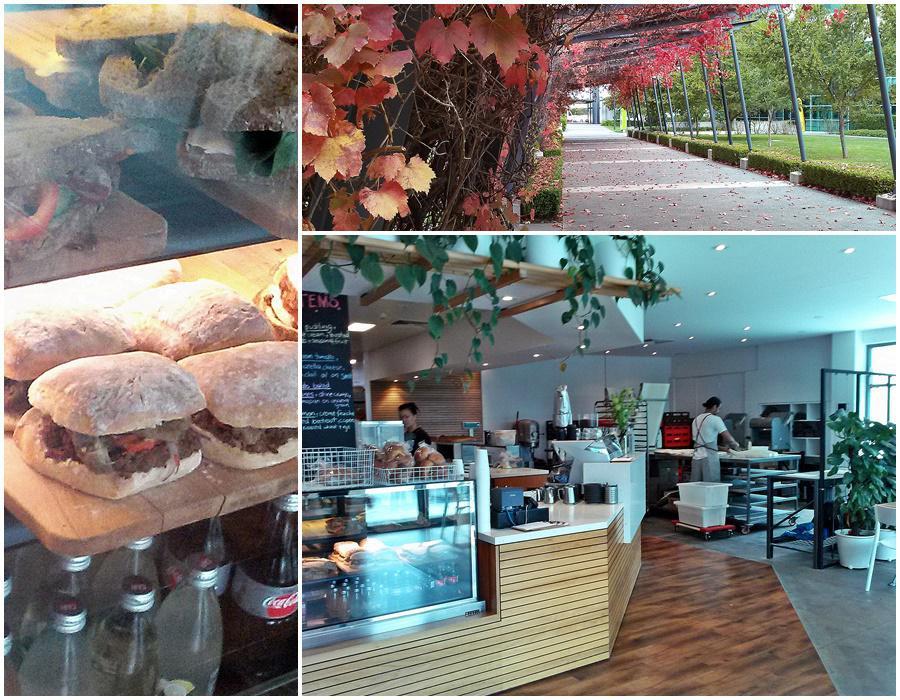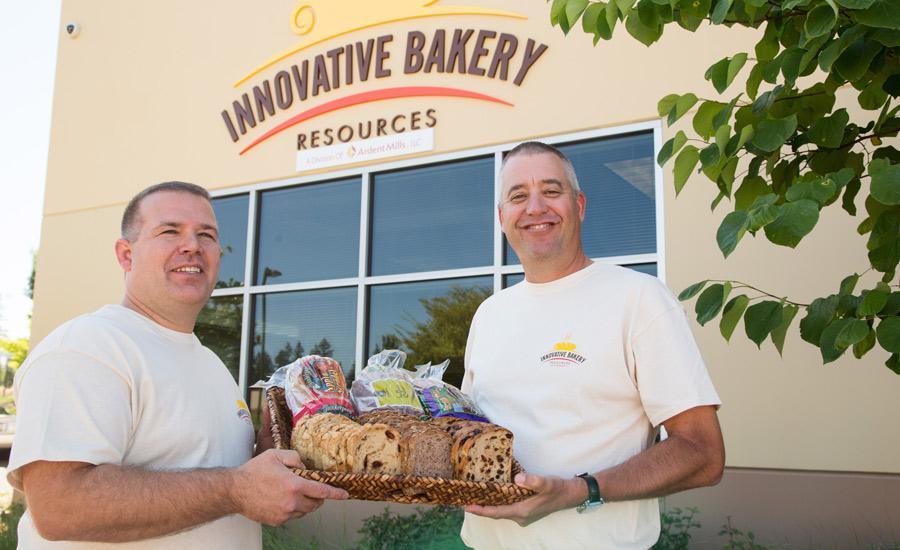The first image is the image on the left, the second image is the image on the right. Analyze the images presented: Is the assertion "One person is standing alone in front of a wooden counter and at least one person is somewhere behind the counter in one image." valid? Answer yes or no. No. 